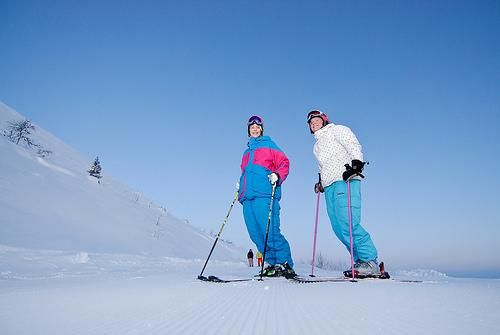What color are the ski poles in the image? Pink and black and white. Explain the clothing and accessories worn by the two women in the image. One woman is wearing a white coat, blue pants, ski goggles, black gloves, and gray ski boots, while the other woman is wearing a blue and pink ski jacket, blue pants, ski goggles, black gloves, and gray ski boots. Both women are holding pink ski poles. What type of natural elements are shown in the background of the image? Evergreen trees, a snow-covered hillside, and clear blue skies. List the main objects and their colors that you can see in the image. evergreen tree, clear blue skies, snow-covered ground, blue ski jacket with pink stripe, ski goggles, snow skis, blue snow pants, black snow gloves, female skier in white coat and blue pants, female skier in pink and blue, pink ski poles, and fuchsia colored ski pole. In three sentences, describe the activities taking place in the image. Two women dressed in colorful ski outfits are skiing on a snow-covered hillside. They are holding ski poles and wearing ski goggles on their heads while standing on their skis. The background features blue skies and evergreen trees on the side of the hill. Are there any trees in the image and if so, how many and what type? Yes, there are evergreen trees on the hillside, and there are two main trees. Mention at least three colors that are present in the image. Blue, pink, and white. What notable colors are present in the clothing that the skiers are wearing? White, blue, and pink. Express the main action happening in the image and where it takes place. Two female skiers are standing next to each other on a snowy hillside with evergreen trees on the side and clear blue skies above. Describe the scene and the position of the people within the frame. Two women are skiing on a snow-covered hillside with evergreen trees and blue skies above. One woman is wearing a white coat and blue pants, while the other is dressed in pink and blue. They are holding ski poles and have goggles on their heads, standing next to each other with skis on. 